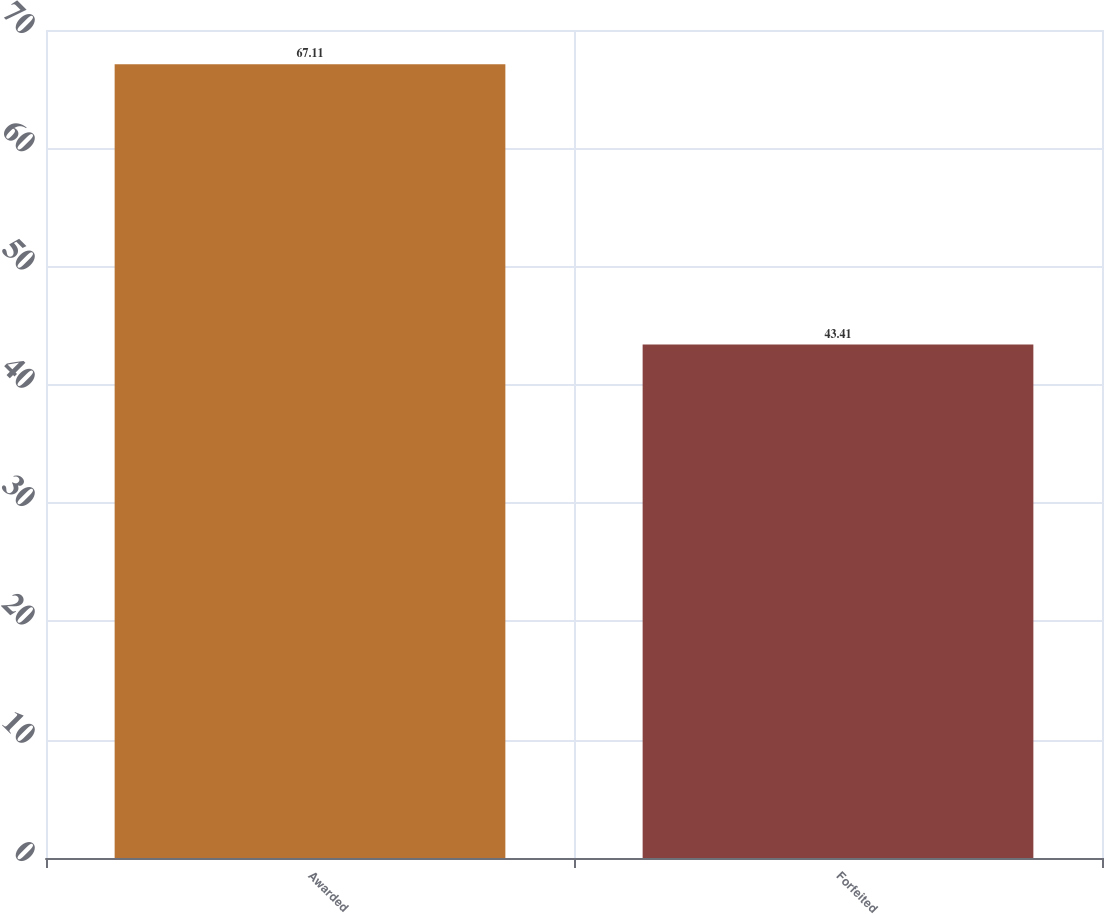Convert chart to OTSL. <chart><loc_0><loc_0><loc_500><loc_500><bar_chart><fcel>Awarded<fcel>Forfeited<nl><fcel>67.11<fcel>43.41<nl></chart> 